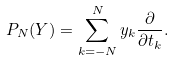Convert formula to latex. <formula><loc_0><loc_0><loc_500><loc_500>P _ { N } ( Y ) = \sum _ { k = - N } ^ { N } y _ { k } \frac { \partial } { \partial t _ { k } } .</formula> 